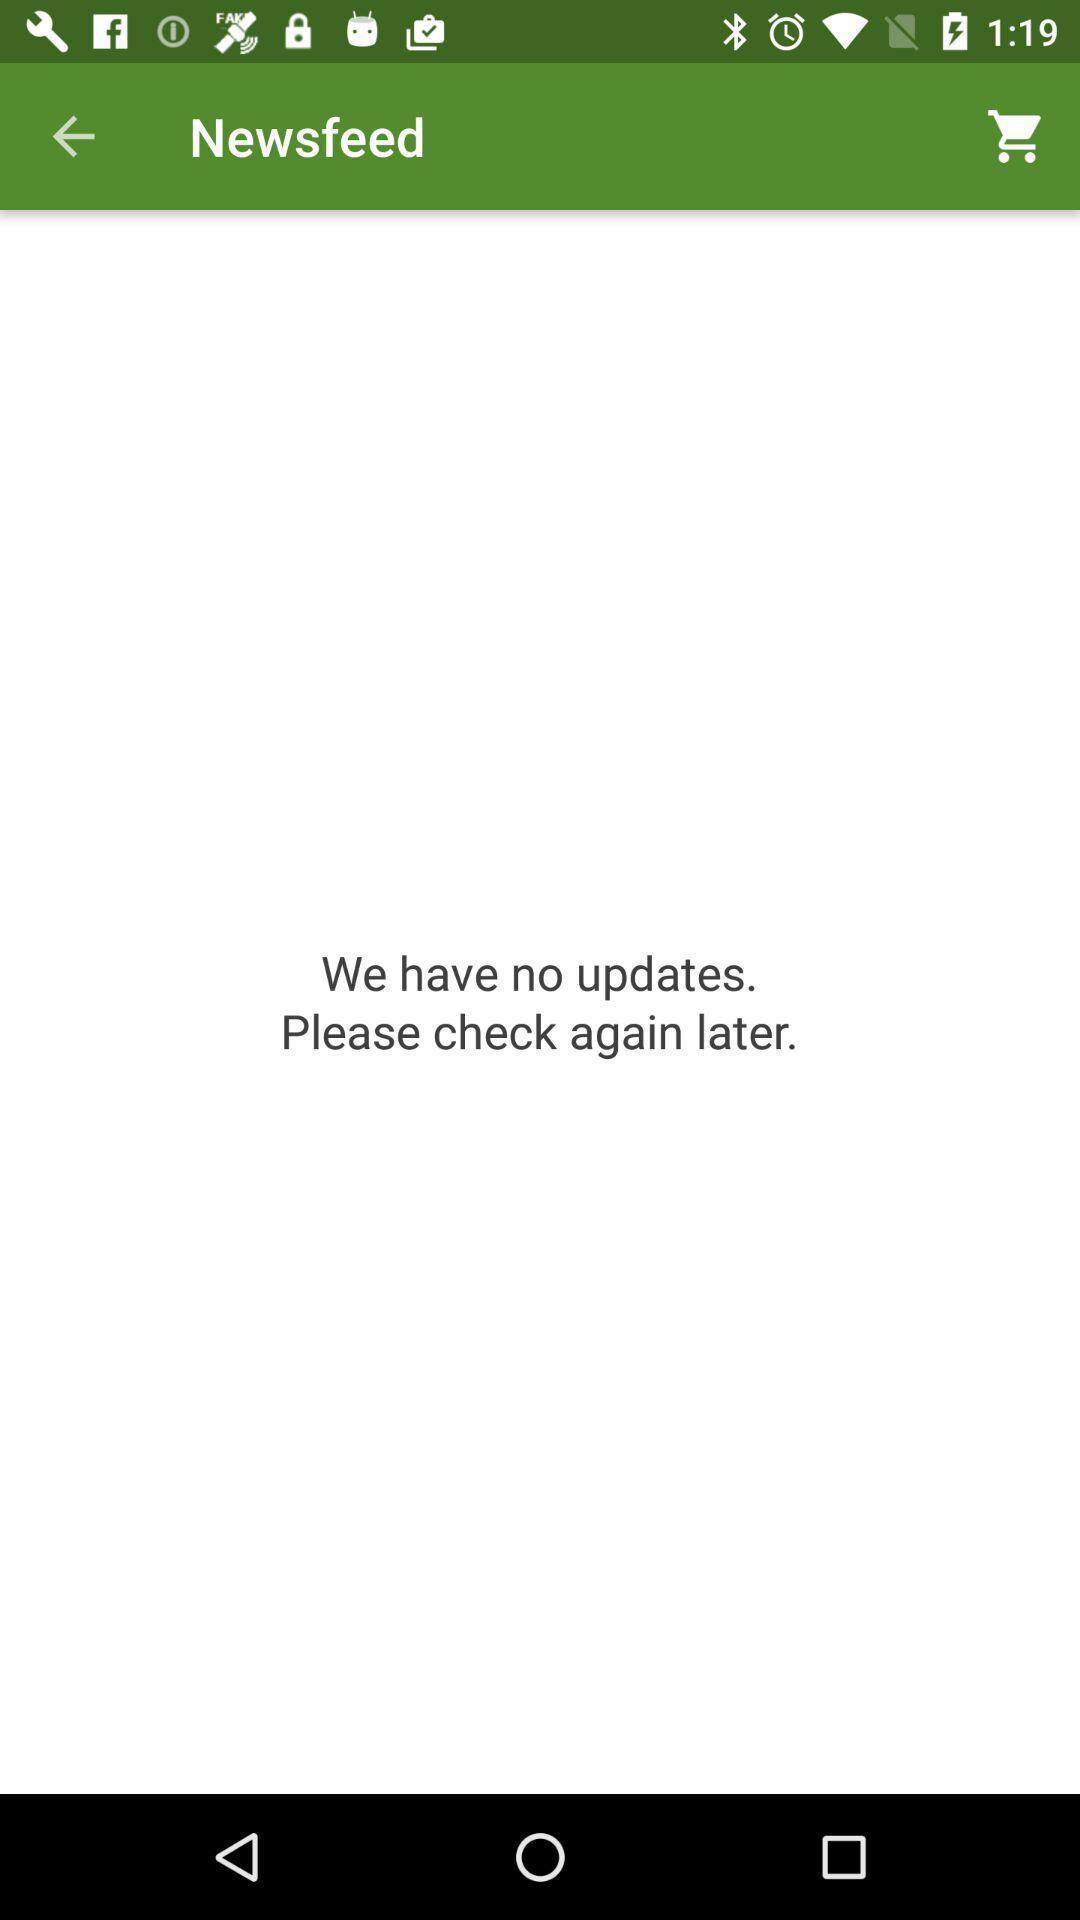Describe the content in this image. Result page showing message after a search in news app. 